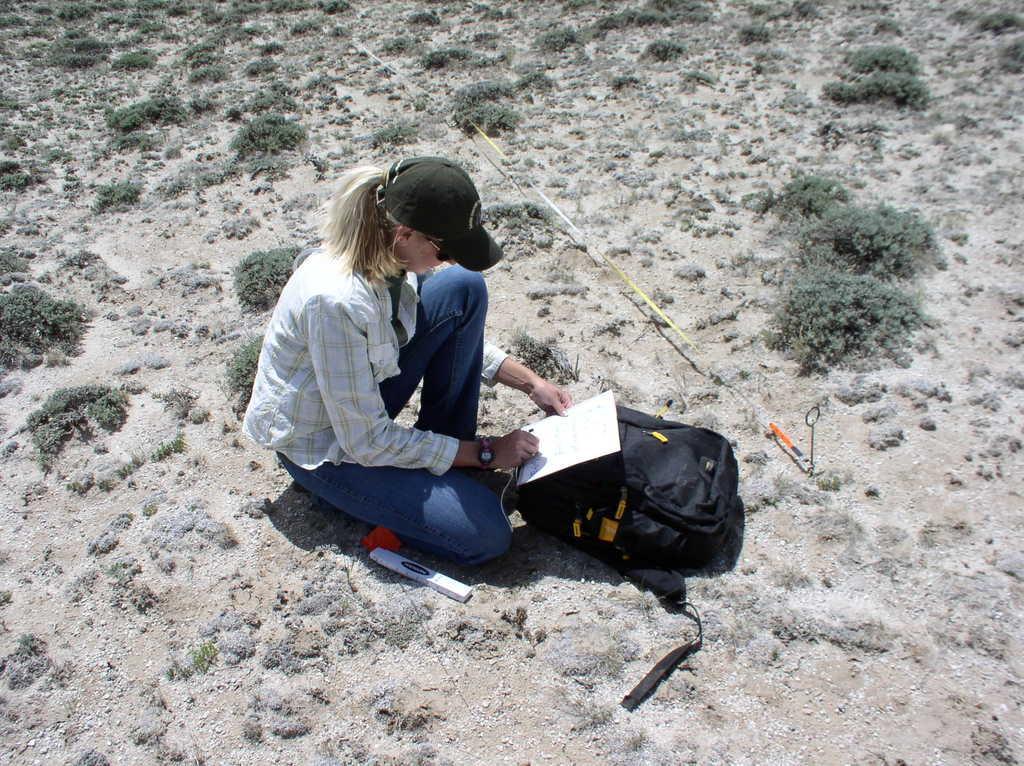Can you describe this image briefly? In this image I can see a woman wearing a cap and holding a paper in front of her there is a bag, beside her there is a small packet , there are small bushes visible on the land, there might be a rope visible in the middle. 